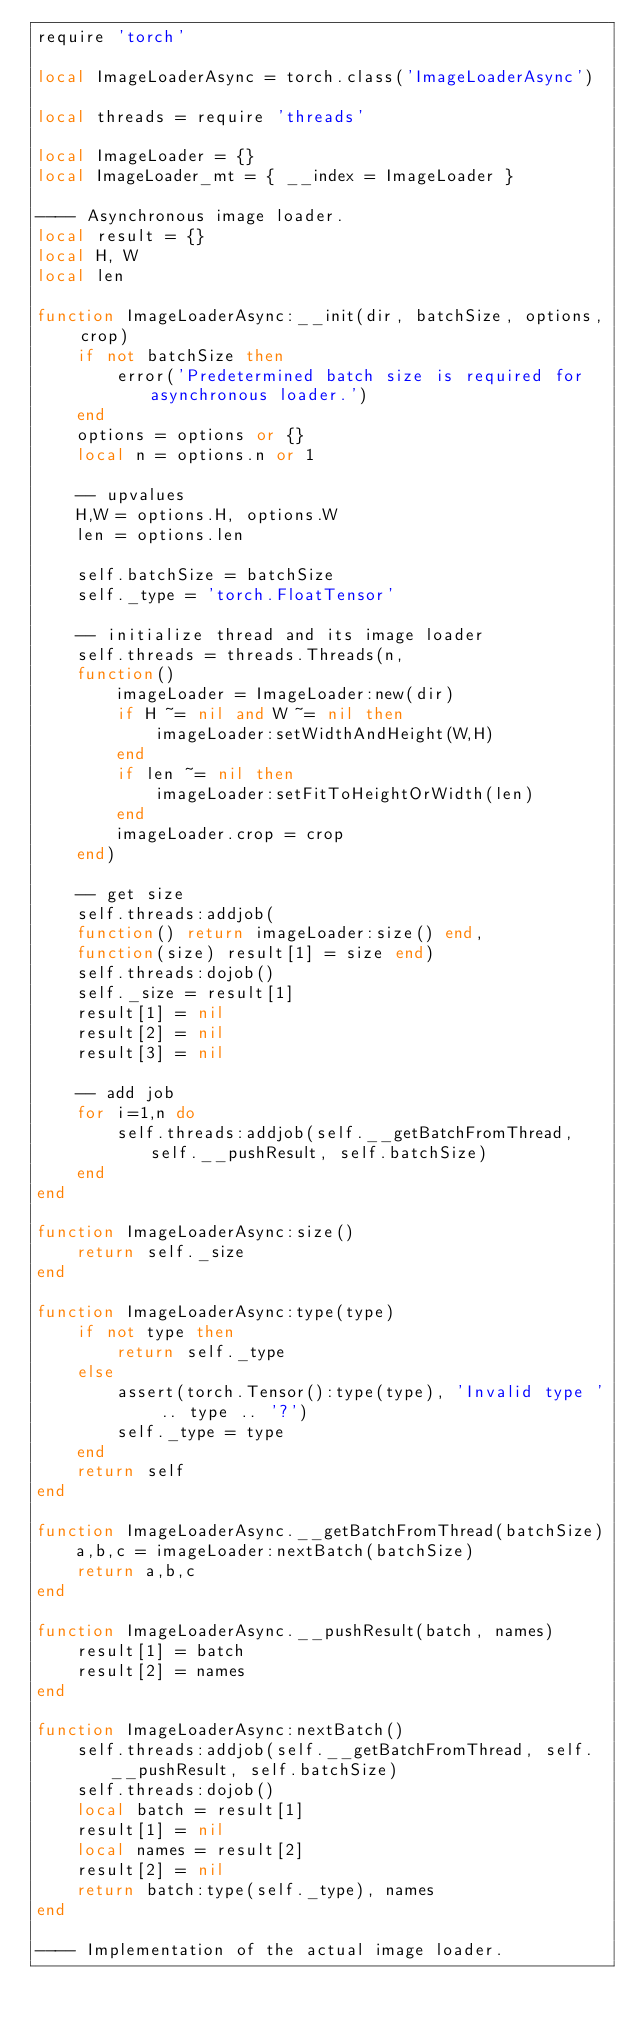Convert code to text. <code><loc_0><loc_0><loc_500><loc_500><_Lua_>require 'torch'

local ImageLoaderAsync = torch.class('ImageLoaderAsync')

local threads = require 'threads'

local ImageLoader = {}
local ImageLoader_mt = { __index = ImageLoader }

---- Asynchronous image loader.
local result = {}
local H, W
local len

function ImageLoaderAsync:__init(dir, batchSize, options, crop)
    if not batchSize then
        error('Predetermined batch size is required for asynchronous loader.')
    end
    options = options or {}
    local n = options.n or 1

    -- upvalues
    H,W = options.H, options.W
    len = options.len

    self.batchSize = batchSize
    self._type = 'torch.FloatTensor'

    -- initialize thread and its image loader
    self.threads = threads.Threads(n,
    function()
        imageLoader = ImageLoader:new(dir)
        if H ~= nil and W ~= nil then
            imageLoader:setWidthAndHeight(W,H)
        end
        if len ~= nil then
            imageLoader:setFitToHeightOrWidth(len)
        end
        imageLoader.crop = crop
    end)

    -- get size
    self.threads:addjob(
    function() return imageLoader:size() end,
    function(size) result[1] = size end)
    self.threads:dojob()
    self._size = result[1]
    result[1] = nil
    result[2] = nil
    result[3] = nil

    -- add job
    for i=1,n do
        self.threads:addjob(self.__getBatchFromThread, self.__pushResult, self.batchSize)
    end
end

function ImageLoaderAsync:size()
    return self._size
end

function ImageLoaderAsync:type(type)
    if not type then
        return self._type
    else
        assert(torch.Tensor():type(type), 'Invalid type ' .. type .. '?')
        self._type = type
    end
    return self
end

function ImageLoaderAsync.__getBatchFromThread(batchSize)
    a,b,c = imageLoader:nextBatch(batchSize)
    return a,b,c
end

function ImageLoaderAsync.__pushResult(batch, names)
    result[1] = batch
    result[2] = names
end

function ImageLoaderAsync:nextBatch()
    self.threads:addjob(self.__getBatchFromThread, self.__pushResult, self.batchSize)
    self.threads:dojob()
    local batch = result[1]
    result[1] = nil
    local names = result[2]
    result[2] = nil
    return batch:type(self._type), names
end

---- Implementation of the actual image loader.</code> 